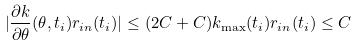<formula> <loc_0><loc_0><loc_500><loc_500>| \frac { \partial k } { \partial \theta } ( \theta , t _ { i } ) r _ { i n } ( t _ { i } ) | \leq ( 2 C + C ) k _ { \max } ( t _ { i } ) r _ { i n } ( t _ { i } ) \leq C</formula> 